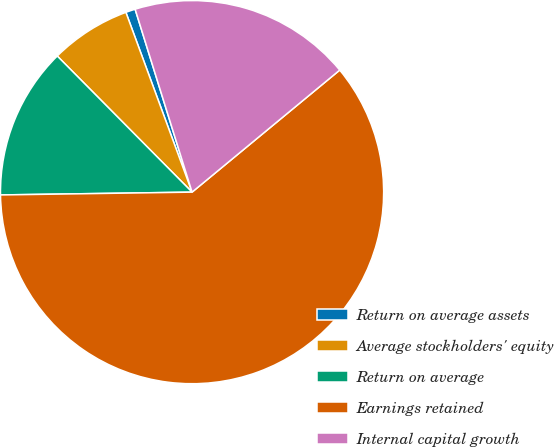<chart> <loc_0><loc_0><loc_500><loc_500><pie_chart><fcel>Return on average assets<fcel>Average stockholders' equity<fcel>Return on average<fcel>Earnings retained<fcel>Internal capital growth<nl><fcel>0.81%<fcel>6.81%<fcel>12.81%<fcel>60.76%<fcel>18.81%<nl></chart> 